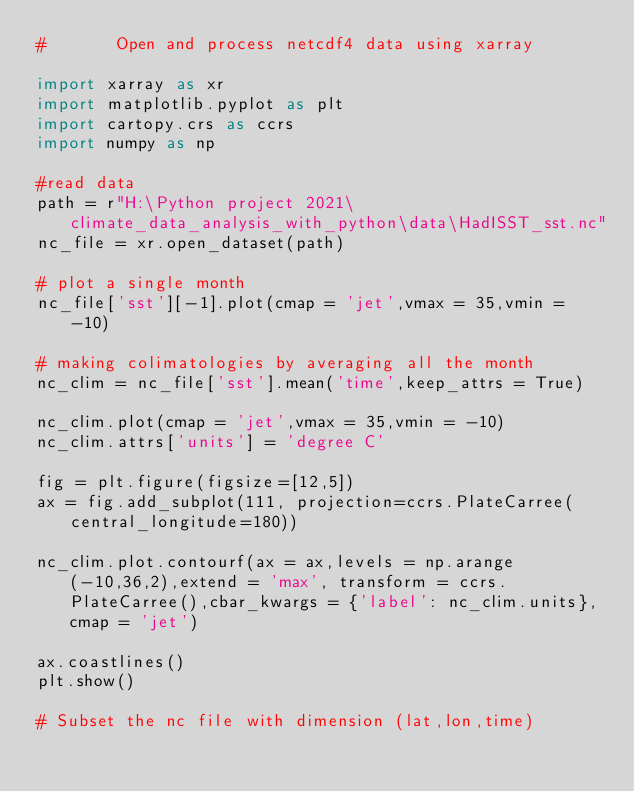<code> <loc_0><loc_0><loc_500><loc_500><_Python_>#       Open and process netcdf4 data using xarray

import xarray as xr
import matplotlib.pyplot as plt
import cartopy.crs as ccrs
import numpy as np

#read data
path = r"H:\Python project 2021\climate_data_analysis_with_python\data\HadISST_sst.nc"
nc_file = xr.open_dataset(path)

# plot a single month
nc_file['sst'][-1].plot(cmap = 'jet',vmax = 35,vmin = -10)

# making colimatologies by averaging all the month
nc_clim = nc_file['sst'].mean('time',keep_attrs = True)

nc_clim.plot(cmap = 'jet',vmax = 35,vmin = -10)
nc_clim.attrs['units'] = 'degree C'

fig = plt.figure(figsize=[12,5])
ax = fig.add_subplot(111, projection=ccrs.PlateCarree(central_longitude=180))

nc_clim.plot.contourf(ax = ax,levels = np.arange(-10,36,2),extend = 'max', transform = ccrs.PlateCarree(),cbar_kwargs = {'label': nc_clim.units},cmap = 'jet')

ax.coastlines()
plt.show()

# Subset the nc file with dimension (lat,lon,time)

</code> 